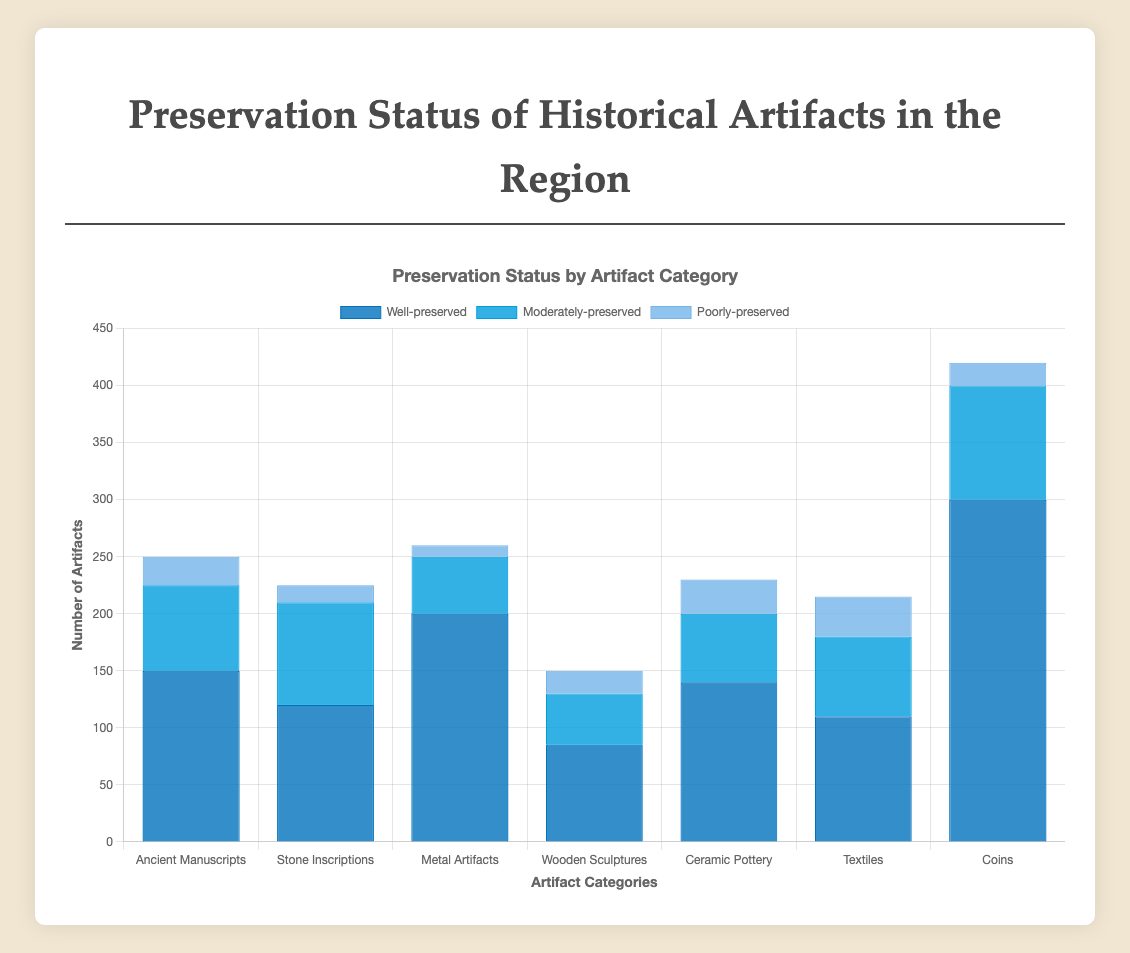Which artifact category has the highest number of well-preserved items? The category with the tallest bar in the 'Well-preserved' section has the most well-preserved items. From the chart, the 'Coins' category has the highest count with 300 well-preserved items.
Answer: Coins How many poorly-preserved items are there in total? Sum the counts for poorly-preserved artifacts across all categories. These are 25 (Ancient Manuscripts) + 15 (Stone Inscriptions) + 10 (Metal Artifacts) + 20 (Wooden Sculptures) + 30 (Ceramic Pottery) + 35 (Textiles) + 20 (Coins). The total is 155.
Answer: 155 Which category has the lowest number of moderately-preserved items? The category with the shortest bar in the 'Moderately-preserved' section has the fewest. From the chart, 'Metal Artifacts' has the lowest count with 50 moderately-preserved items.
Answer: Metal Artifacts How does the number of well-preserved Ceramic Pottery compare to the number of well-preserved Textiles? Compare the heights of the bars in the 'Well-preserved' section for these two categories. Ceramic Pottery has 140 well-preserved items while Textiles have 110. Thus, there are more well-preserved Ceramic Pottery than Textiles.
Answer: More Ceramic Pottery What is the total count of artifacts in the 'Ancient Manuscripts' category? Sum the counts of well-preserved, moderately-preserved, and poorly-preserved artifacts in the 'Ancient Manuscripts' category: 150 (Well-preserved) + 75 (Moderately-preserved) + 25 (Poorly-preserved) = 250.
Answer: 250 Which preservation status has the most artifacts in the 'Stone Inscriptions' category? Compare the heights of the bars in the 'Stone Inscriptions' section. The 'Moderately-preserved' bar is the tallest, indicating the most artifacts in this status with 90 items.
Answer: Moderately-preserved How many more well-preserved Metal Artifacts are there compared to poorly-preserved ones? Subtract the count of poorly-preserved Metal Artifacts from well-preserved ones: 200 (Well-preserved) - 10 (Poorly-preserved) = 190.
Answer: 190 What is the average number of moderately-preserved artifacts across all categories? Sum the counts of moderately-preserved artifacts across all categories and divide by the number of categories. (75 + 90 + 50 + 45 + 60 + 70 + 100) / 7 = 70.
Answer: 70 Among all the categories, which has the smallest total count of artifacts? Sum the counts of all status types for each category and identify the smallest. For 'Wooden Sculptures': 85 + 45 + 20 = 150, the smallest among all categories.
Answer: Wooden Sculptures Compare the total number of well-preserved and poorly-preserved artifacts across all categories. Which is higher? Sum the counts of well-preserved and poorly-preserved artifacts across all categories and compare. 
Well-preserved: 150 + 120 + 200 + 85 + 140 + 110 + 300 = 1105.
Poorly-preserved: 25 + 15 + 10 + 20 + 30 + 35 + 20 = 155.
Well-preserved is higher.
Answer: Well-preserved 